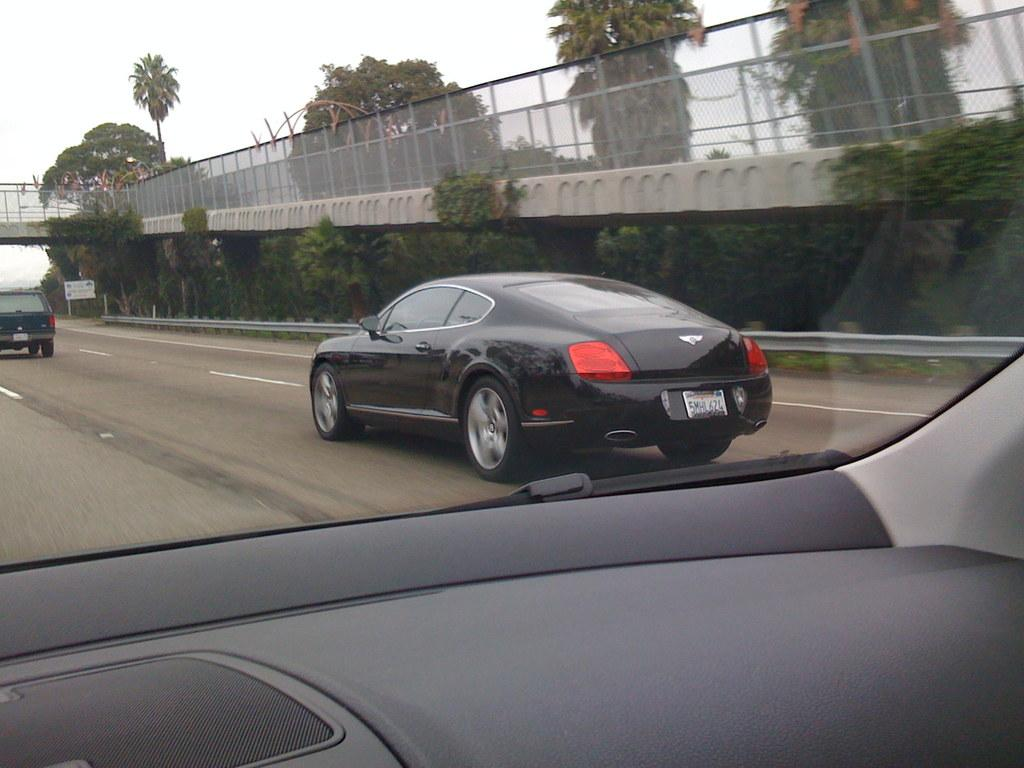What is the vantage point of the image? The picture is taken from a car. What can be seen in the foreground of the image? There are cars, a road, trees, plants, and a bridge in the foreground of the image. What is the condition of the sky in the image? The sky is cloudy in the image. Where is the volleyball court located in the image? There is no volleyball court present in the image. What type of art can be seen on the bridge in the image? There is no art visible on the bridge in the image. 